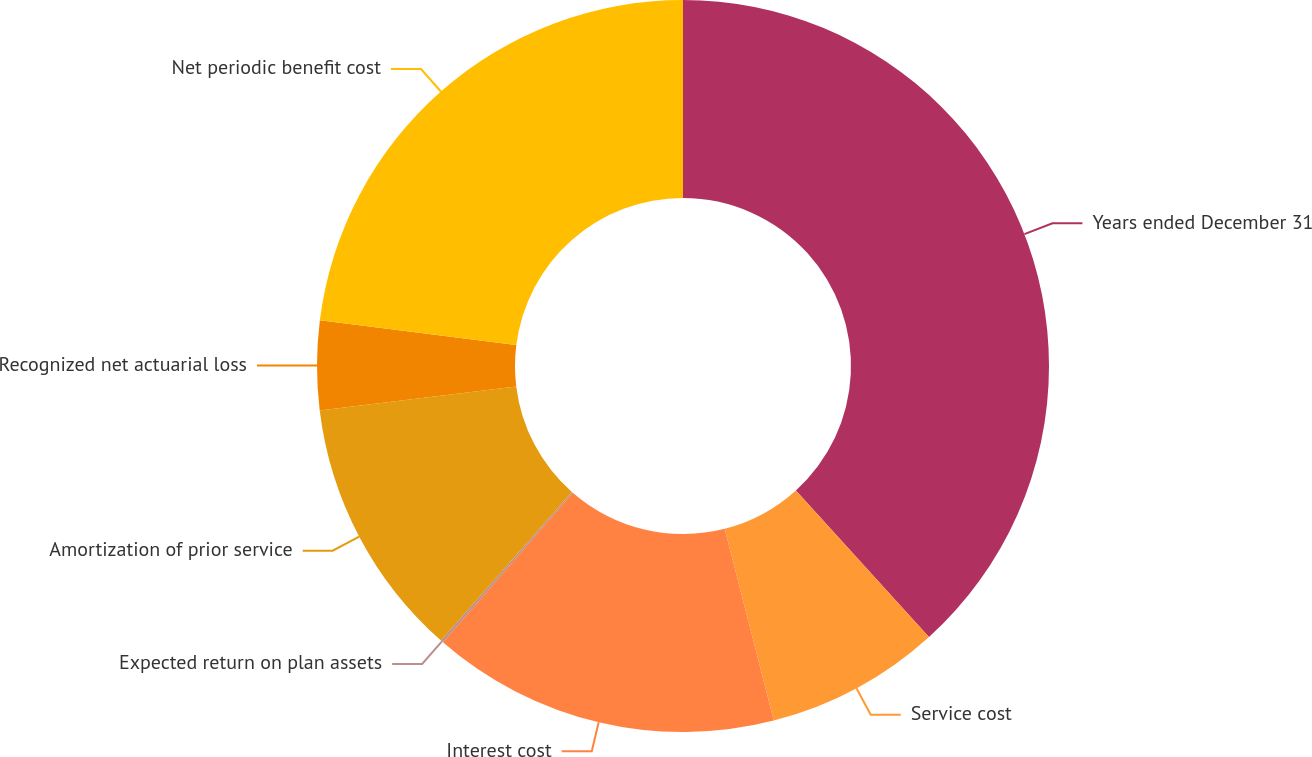Convert chart. <chart><loc_0><loc_0><loc_500><loc_500><pie_chart><fcel>Years ended December 31<fcel>Service cost<fcel>Interest cost<fcel>Expected return on plan assets<fcel>Amortization of prior service<fcel>Recognized net actuarial loss<fcel>Net periodic benefit cost<nl><fcel>38.27%<fcel>7.74%<fcel>15.38%<fcel>0.11%<fcel>11.56%<fcel>3.93%<fcel>23.01%<nl></chart> 